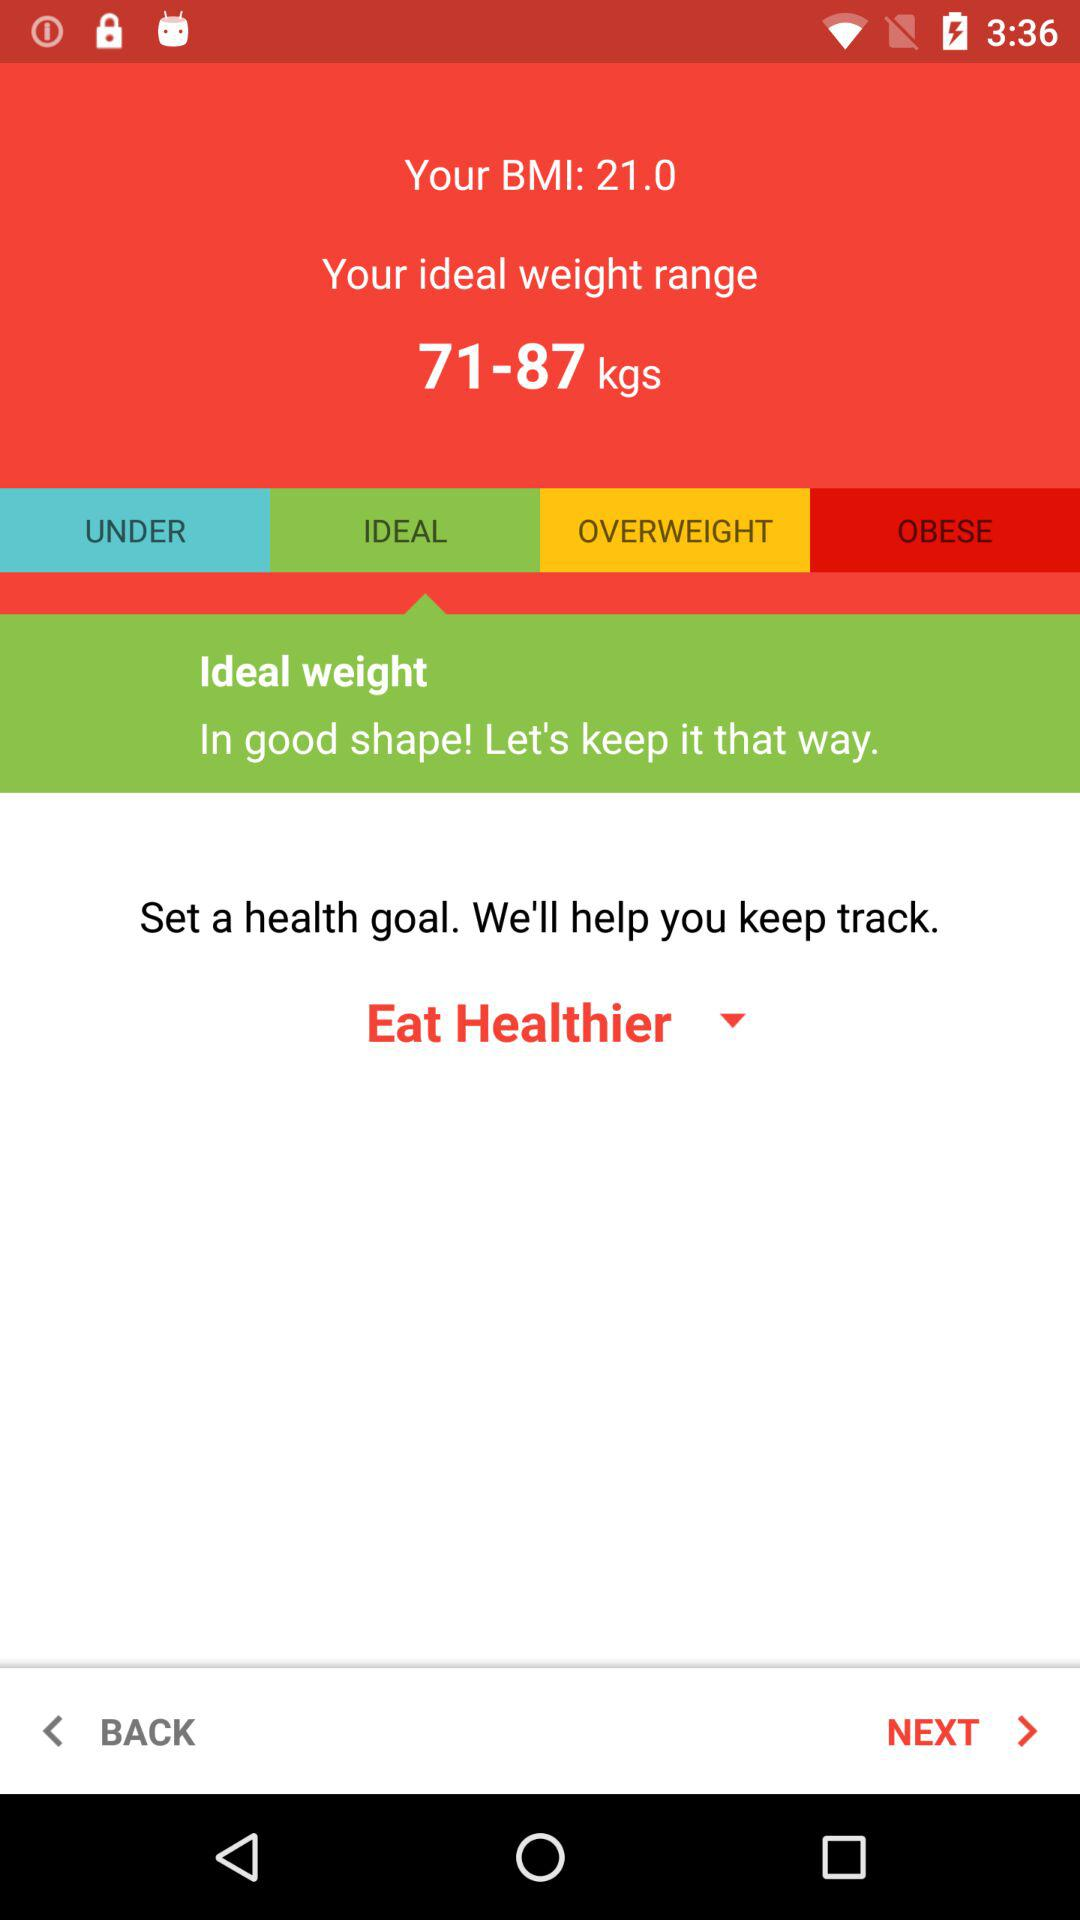What is the BMI? The BMI is 21.0. 